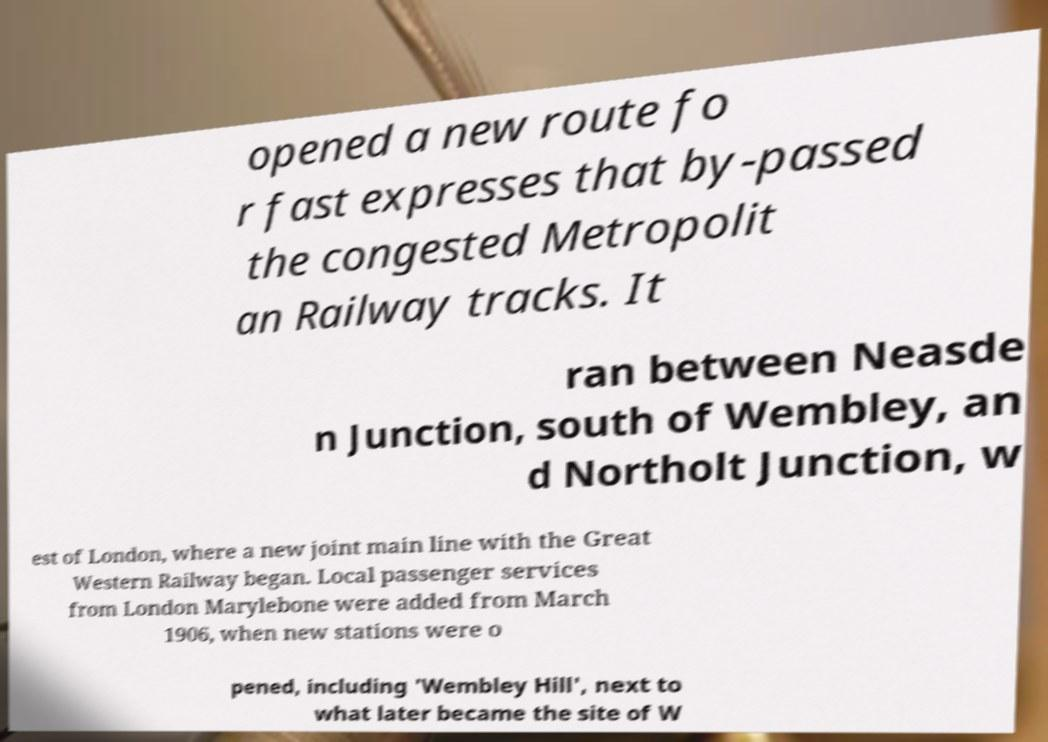Can you read and provide the text displayed in the image?This photo seems to have some interesting text. Can you extract and type it out for me? opened a new route fo r fast expresses that by-passed the congested Metropolit an Railway tracks. It ran between Neasde n Junction, south of Wembley, an d Northolt Junction, w est of London, where a new joint main line with the Great Western Railway began. Local passenger services from London Marylebone were added from March 1906, when new stations were o pened, including 'Wembley Hill', next to what later became the site of W 